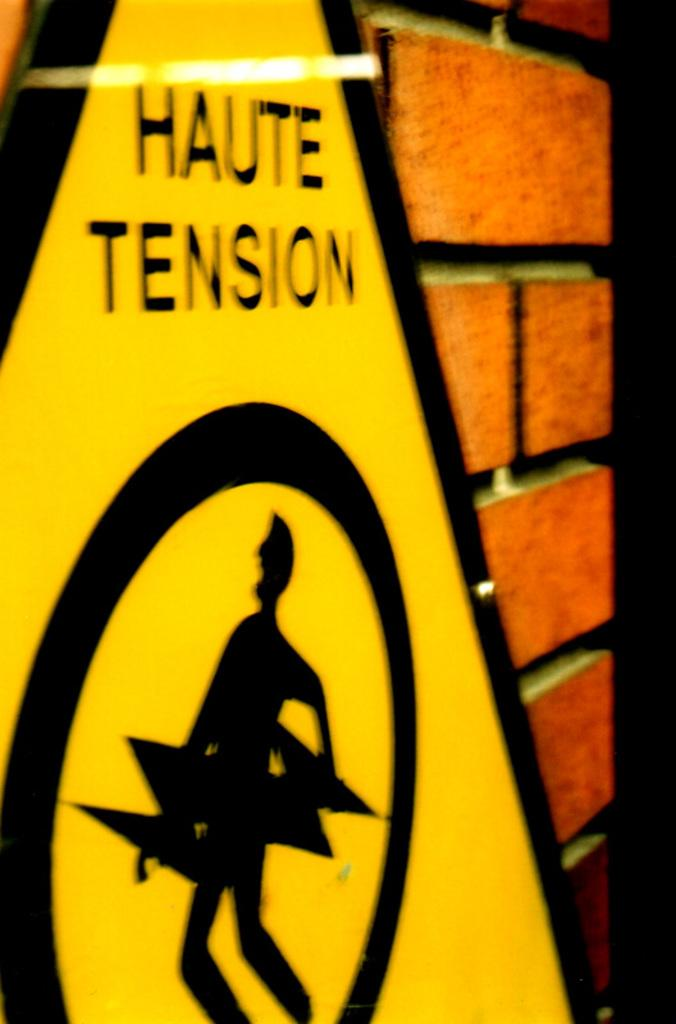What is on the wall in the image? There is a board on the wall in the image. What is written or displayed on the board? There is text on the board and a sign on the board. What can be seen behind the board in the image? There is a wall visible at the back of the image. Can you tell me how many leaves are on the board in the image? There are no leaves present on the board in the image. Is there a minister standing next to the board in the image? There is no minister present in the image. 